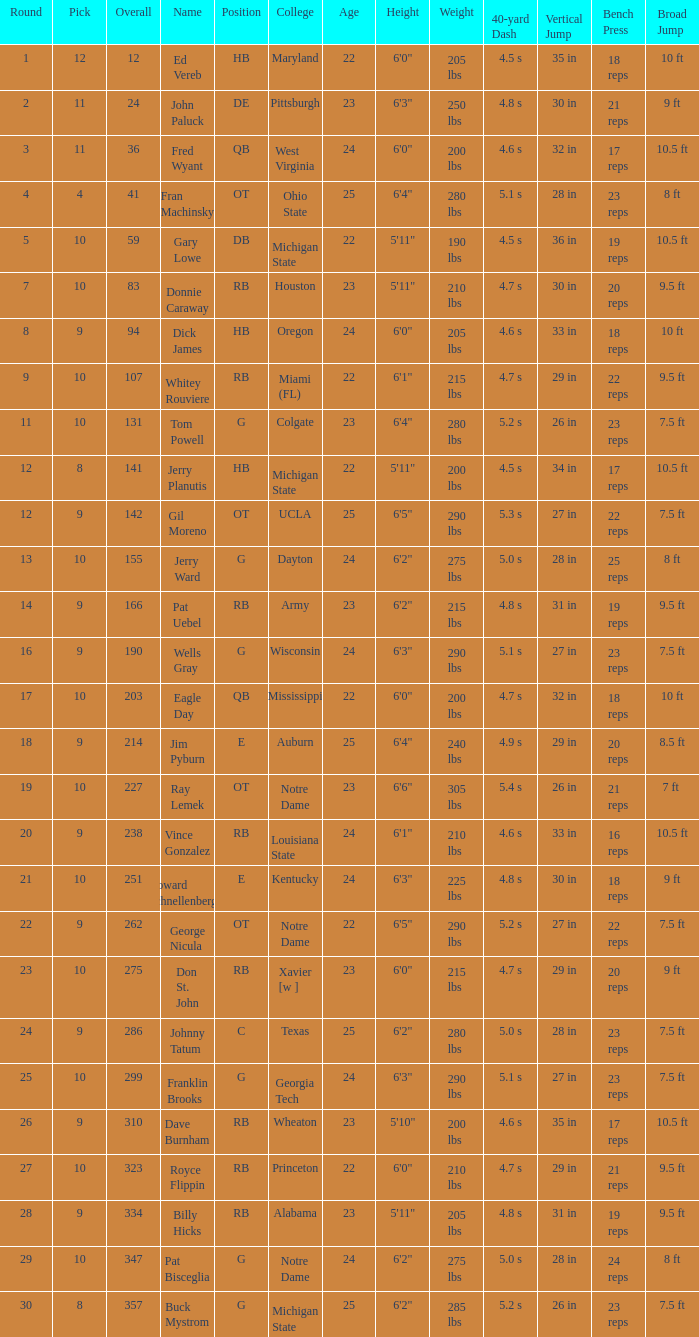What is the total of rounds that has a selection of 9 and is called jim pyburn? 18.0. 